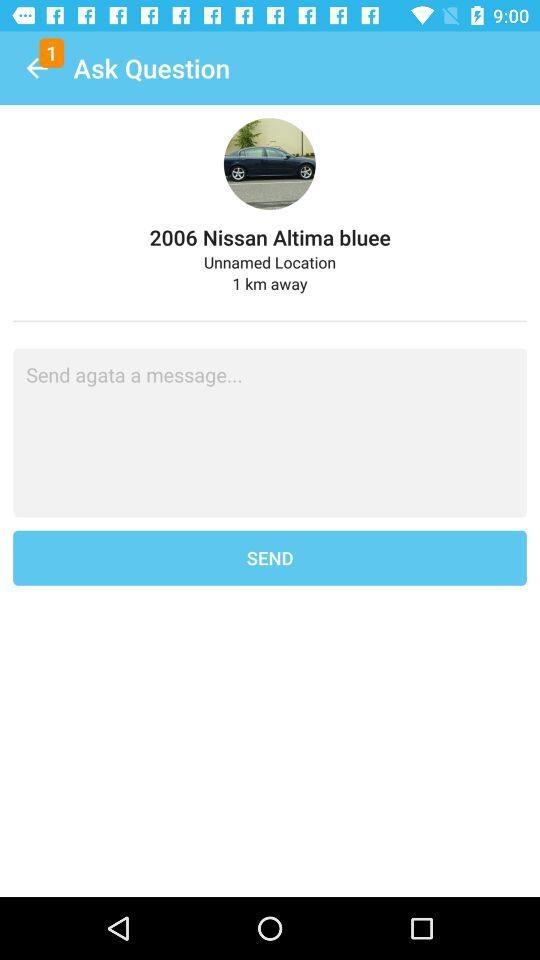How many kilometers away is the car?
Answer the question using a single word or phrase. 1 